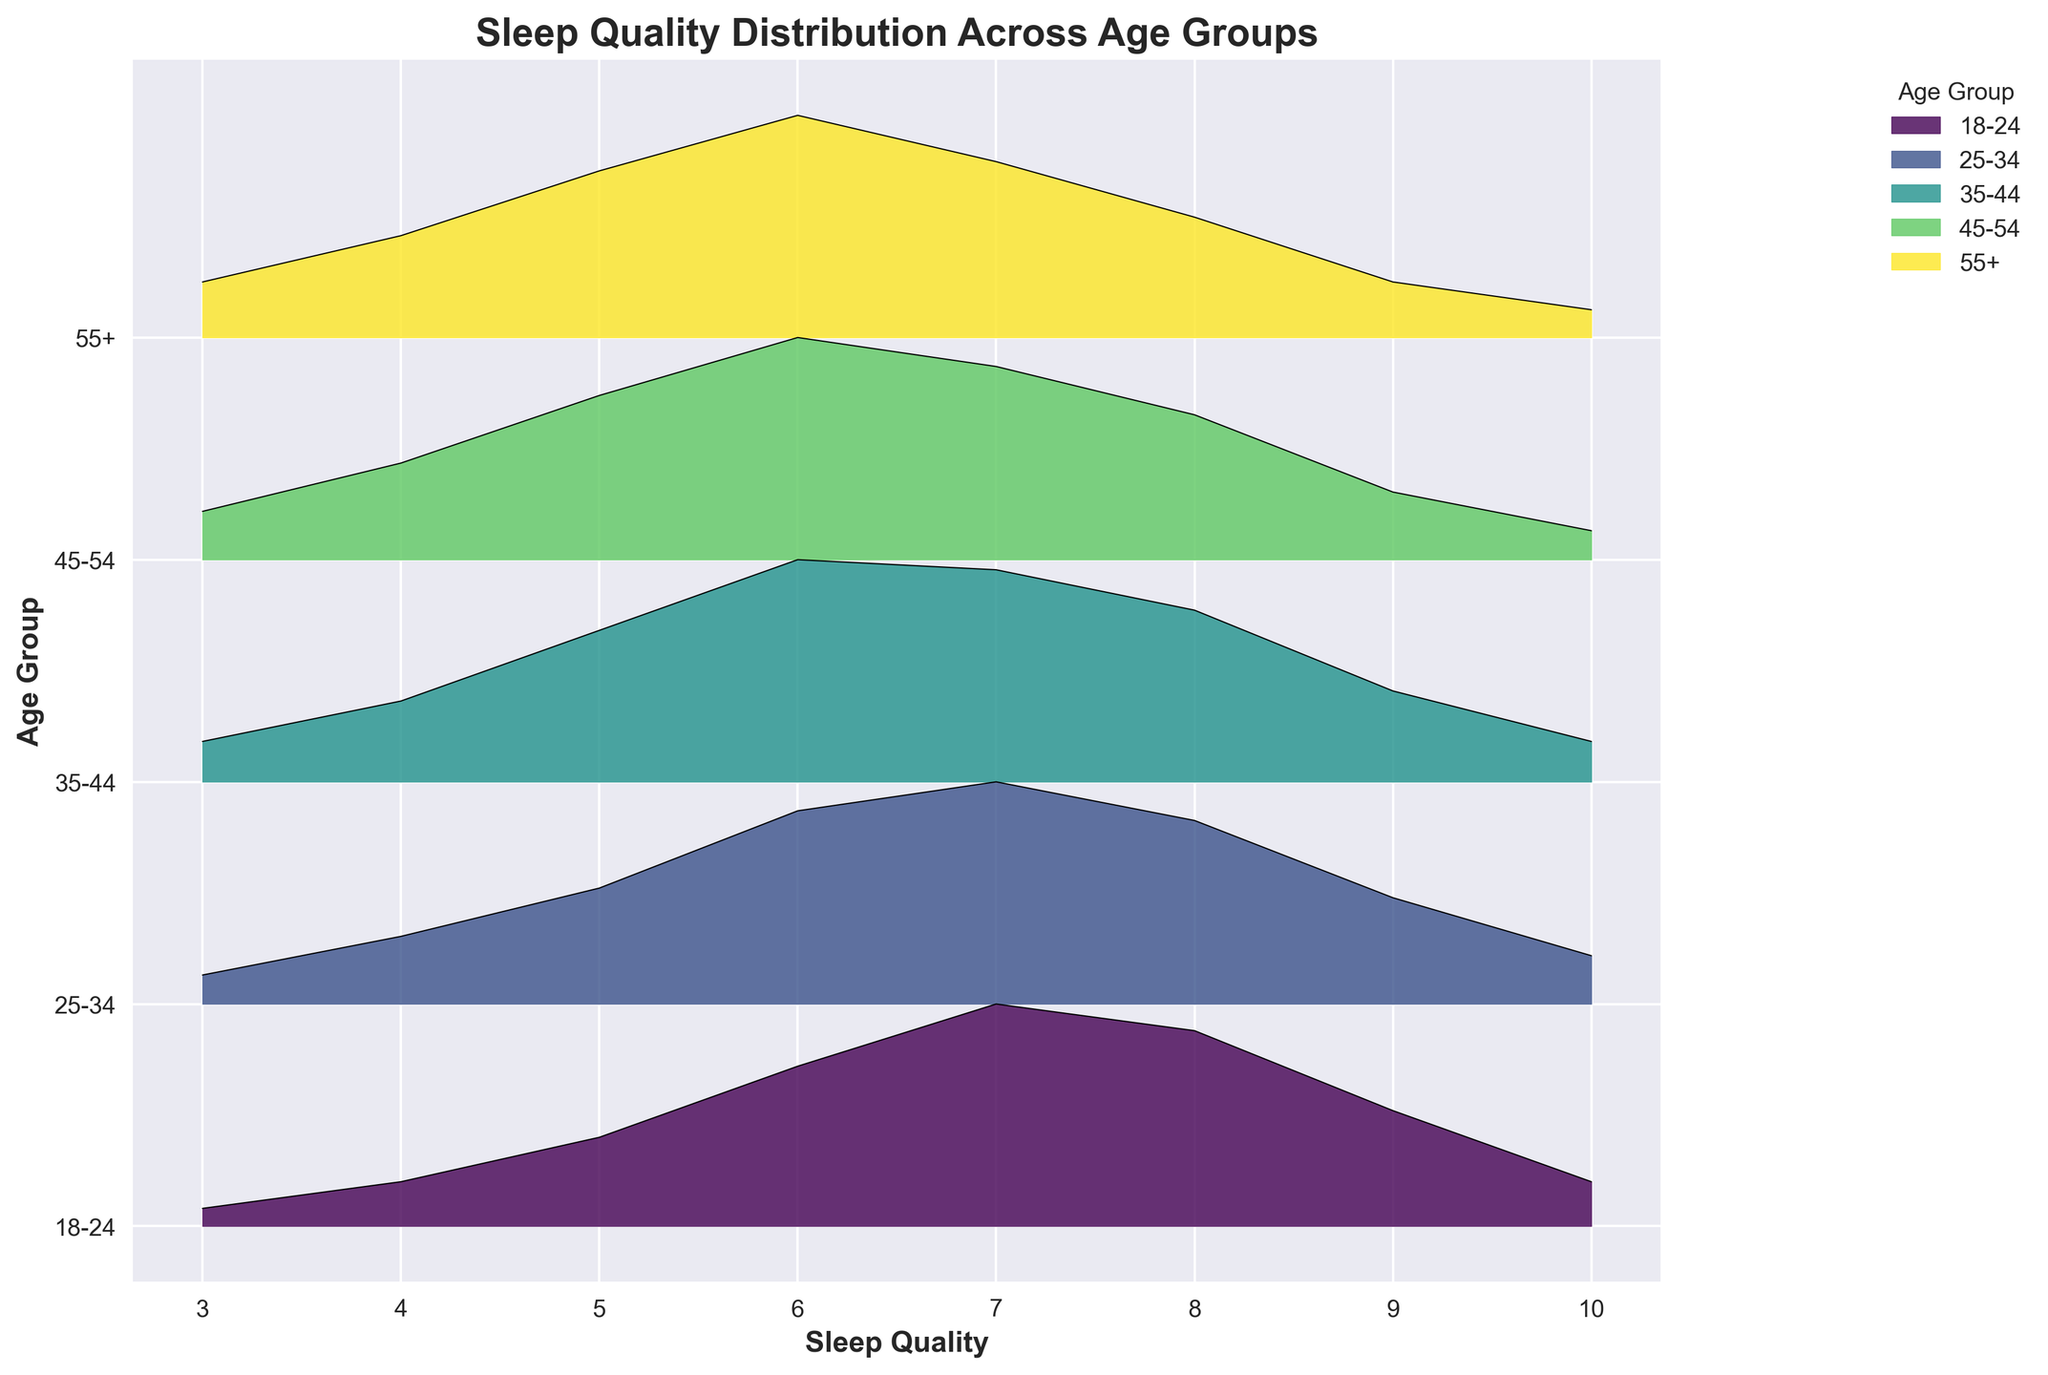What is the title of the plot? The title of the plot is displayed at the top and is in bold font. It helps in understanding the main topic the plot is covering.
Answer: Sleep Quality Distribution Across Age Groups What are the labels on the x-axis and y-axis? The x-axis label is 'Sleep Quality,' and the y-axis label is 'Age Group.' These labels describe what data is represented on each axis.
Answer: Sleep Quality, Age Group Which age group has the highest density for sleep quality of 7? Looking at the peaks at sleep quality 7 across all ridges, the tallest peak indicates the highest density.
Answer: 18-24 How does the sleep quality distribution change with increasing age groups? As age groups increase from 18-24 to 55+, the peak of sleep quality distribution tends to shift leftwards, indicating a decrease in higher sleep quality scores.
Answer: Shifts leftwards Which age group shows the widest distribution of sleep quality scores? The widest distribution covers the most range on the x-axis and can be identified by observing the spread of the ridgeline.
Answer: 55+ For which sleep quality score do the age groups 25-34 and 35-44 have the same density? Comparing the density points along the x-axis, look for where both ridges meet at the same density level for sleep quality scores.
Answer: 4 What is the general trend in sleep quality from the age group 18-24 to 55+? Observing the overall positions of peaks in the ridgelines, the trend can be identified by noting if the peaks are moving left or right on the x-axis as age increases.
Answer: Decreases Which age group has the least variation in sleep quality scores? The least variation is indicated by the narrowest spread in the distribution of sleep quality scores on the ridgeline.
Answer: 18-24 Which age group has the highest density for sleep quality of 10? Check the peaks at sleep quality 10 across all the ridgelines to find the tallest peak.
Answer: 18-24 For the age group 45-54, what is the range of sleep quality scores? Identify the lowest and highest sleep quality scores with visible densities for the 45-54 age group. The range is calculated by the difference between these scores.
Answer: 3 to 10 